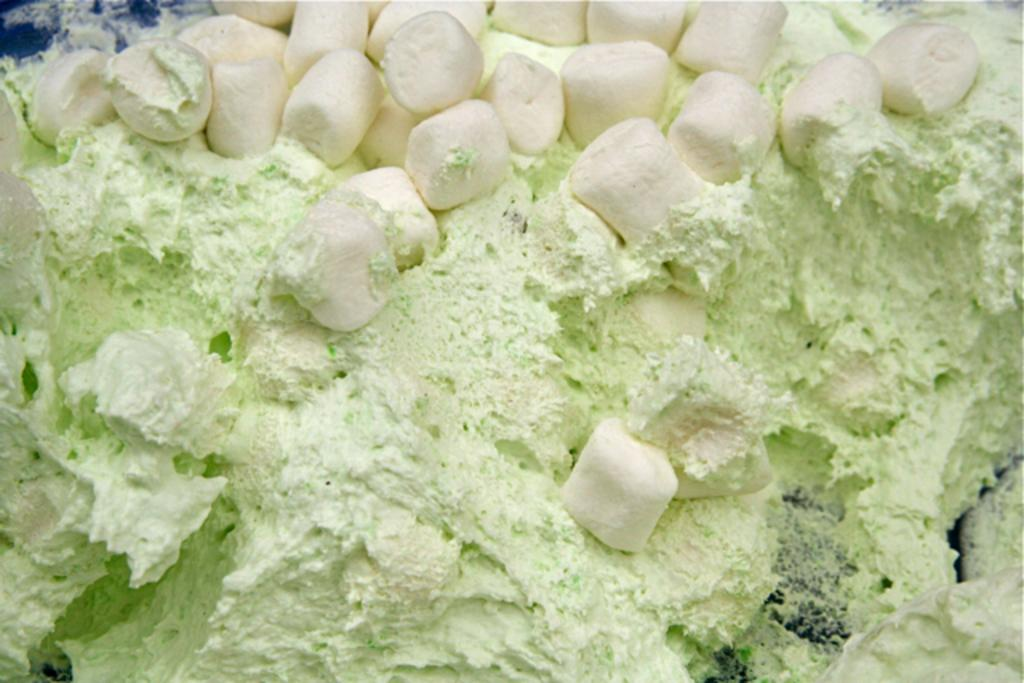What type of food can be seen in the image? There are marshmallows in the image. What other ingredient is present in the image? There is cream in the image. What thoughts are the marshmallows having in the image? Marshmallows do not have thoughts, as they are inanimate objects. How does the wealth of the giants in the image affect the marshmallows? There are no giants or wealth mentioned in the image, so this question cannot be answered. 